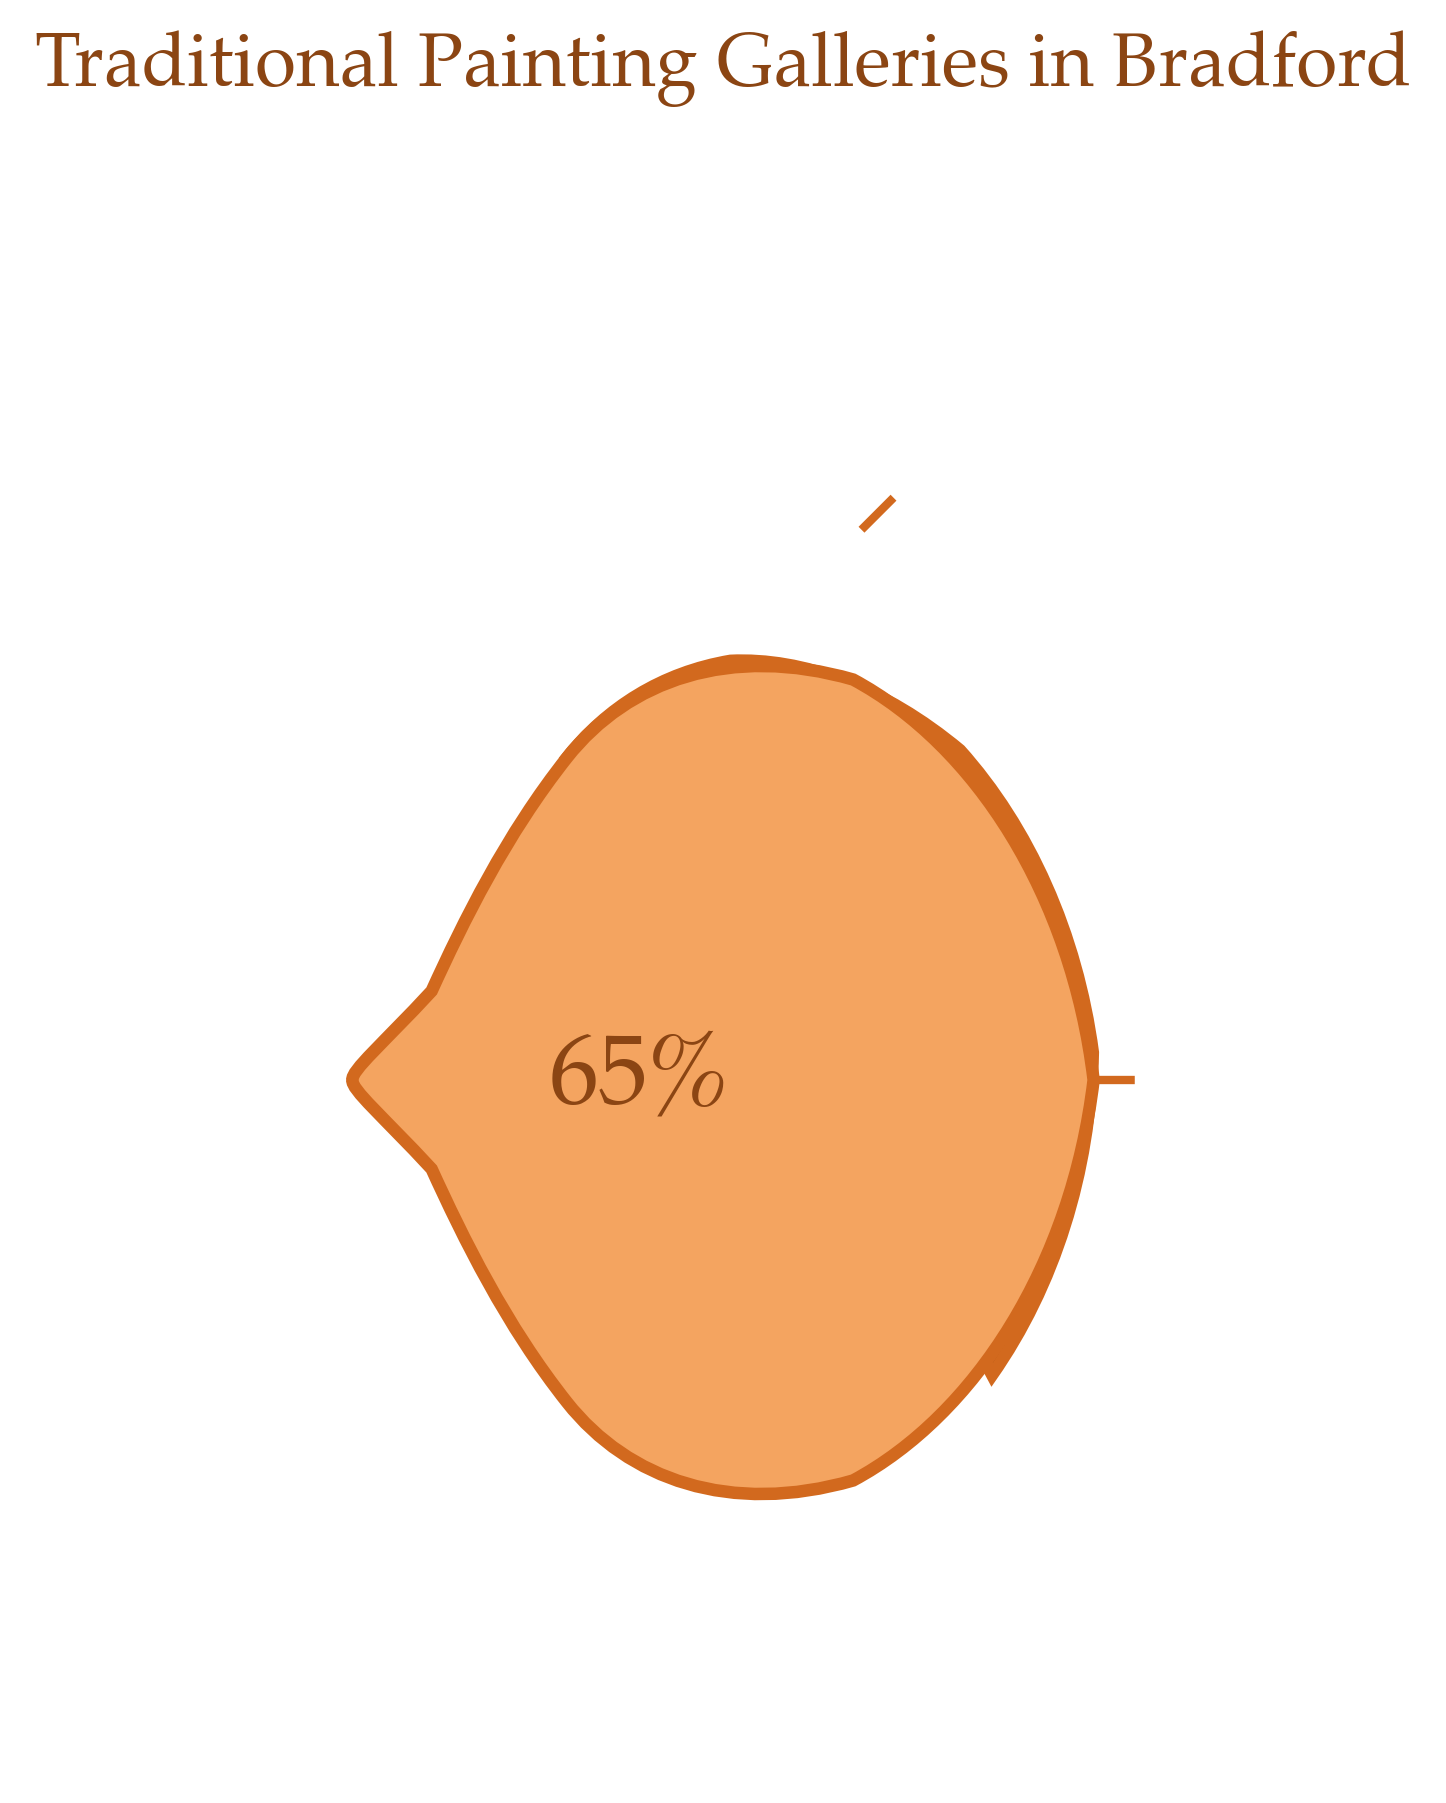What's the title of the gauge chart? The title of the gauge chart is displayed prominently at the top of the figure. It is a direct indication of what the plot is representing.
Answer: Traditional Painting Galleries in Bradford What is the percentage of art galleries featuring traditional painting techniques in Bradford? The percentage of art galleries featuring traditional painting techniques in Bradford is depicted within the gauge of the chart. It is written as a text and pointed to by the wedge on the gauge.
Answer: 65% What color is used for the wedge that represents traditional painting galleries? The wedge representing traditional painting galleries is colored, which can be observed directly from the visual elements of the chart.
Answer: Brown By how much is the percentage of traditional painting galleries greater than modern art spaces? The gauge chart specifies the percentage of traditional painting (65%) and modern art spaces (35%). To find the difference, subtract the smaller percentage from the larger percentage. 65% - 35% = 30%
Answer: 30% What decorative elements are added to the gauge chart? The decorative elements can be observed around the gauge chart, which include lines emanating from the center at various angles.
Answer: Decorative radial lines What does the number at the bottom center of the gauge represent? The number displayed at the bottom center of the gauge indicates the percentage of art galleries featuring traditional painting techniques, as highlighted by the wedge.
Answer: 65% Are more art galleries in Bradford featuring traditional painting techniques or modern art spaces? By comparing the percentages provided in the chart, the traditional painting galleries (65%) have a higher percentage than modern art spaces (35%).
Answer: Traditional painting techniques What is the combined percentage of galleries featuring either traditional painting techniques or modern art spaces? The chart gives two percentages: 65% for traditional painting and 35% for modern art. Summing these will give the combined percentage. 65% + 35% = 100%
Answer: 100% How is the background of the gauge chart styled in terms of color? The background of the gauge chart is visually shown as a certain color, enhancing the thematic appearance of the chart.
Answer: Sandy brown Is the text indicating the percentage written in a sans-serif or serif font? The style of the text can be deduced by looking at its typeface, which is used for the percentage inside the chart. A serif font has decorative strokes at the ends of letters.
Answer: Serif font 